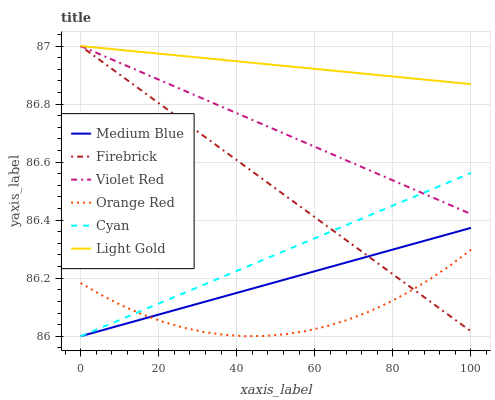Does Firebrick have the minimum area under the curve?
Answer yes or no. No. Does Firebrick have the maximum area under the curve?
Answer yes or no. No. Is Medium Blue the smoothest?
Answer yes or no. No. Is Medium Blue the roughest?
Answer yes or no. No. Does Firebrick have the lowest value?
Answer yes or no. No. Does Medium Blue have the highest value?
Answer yes or no. No. Is Orange Red less than Violet Red?
Answer yes or no. Yes. Is Light Gold greater than Orange Red?
Answer yes or no. Yes. Does Orange Red intersect Violet Red?
Answer yes or no. No. 